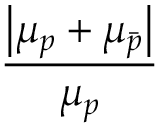Convert formula to latex. <formula><loc_0><loc_0><loc_500><loc_500>\frac { \left | \mu _ { p } + \mu _ { \bar { p } } \right | } { \mu _ { p } }</formula> 